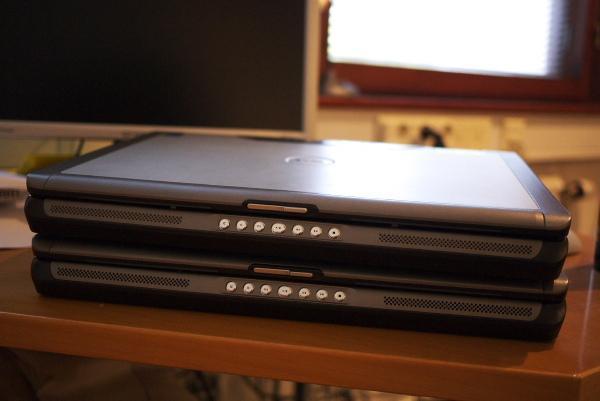How many laptops?
Give a very brief answer. 2. How many laptops are there?
Give a very brief answer. 2. 